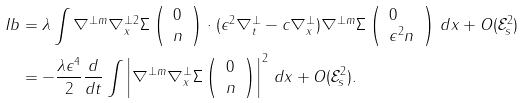<formula> <loc_0><loc_0><loc_500><loc_500>I b & = \lambda \int \nabla ^ { \perp m } \nabla _ { x } ^ { \perp 2 } \Sigma \left ( \begin{array} { l } 0 \\ n \end{array} \right ) \cdot ( \epsilon ^ { 2 } \nabla ^ { \perp } _ { t } - c \nabla ^ { \perp } _ { x } ) \nabla ^ { \perp m } \Sigma \left ( \begin{array} { l } 0 \\ \epsilon ^ { 2 } n \end{array} \right ) \, d x + O ( \mathcal { E } _ { s } ^ { 2 } ) \\ & = - \frac { \lambda \epsilon ^ { 4 } } { 2 } \frac { d } { d t } \int \left | \nabla ^ { \perp m } \nabla _ { x } ^ { \perp } \Sigma \left ( \begin{array} { l } 0 \\ n \end{array} \right ) \right | ^ { 2 } \, d x + O ( \mathcal { E } _ { s } ^ { 2 } ) .</formula> 